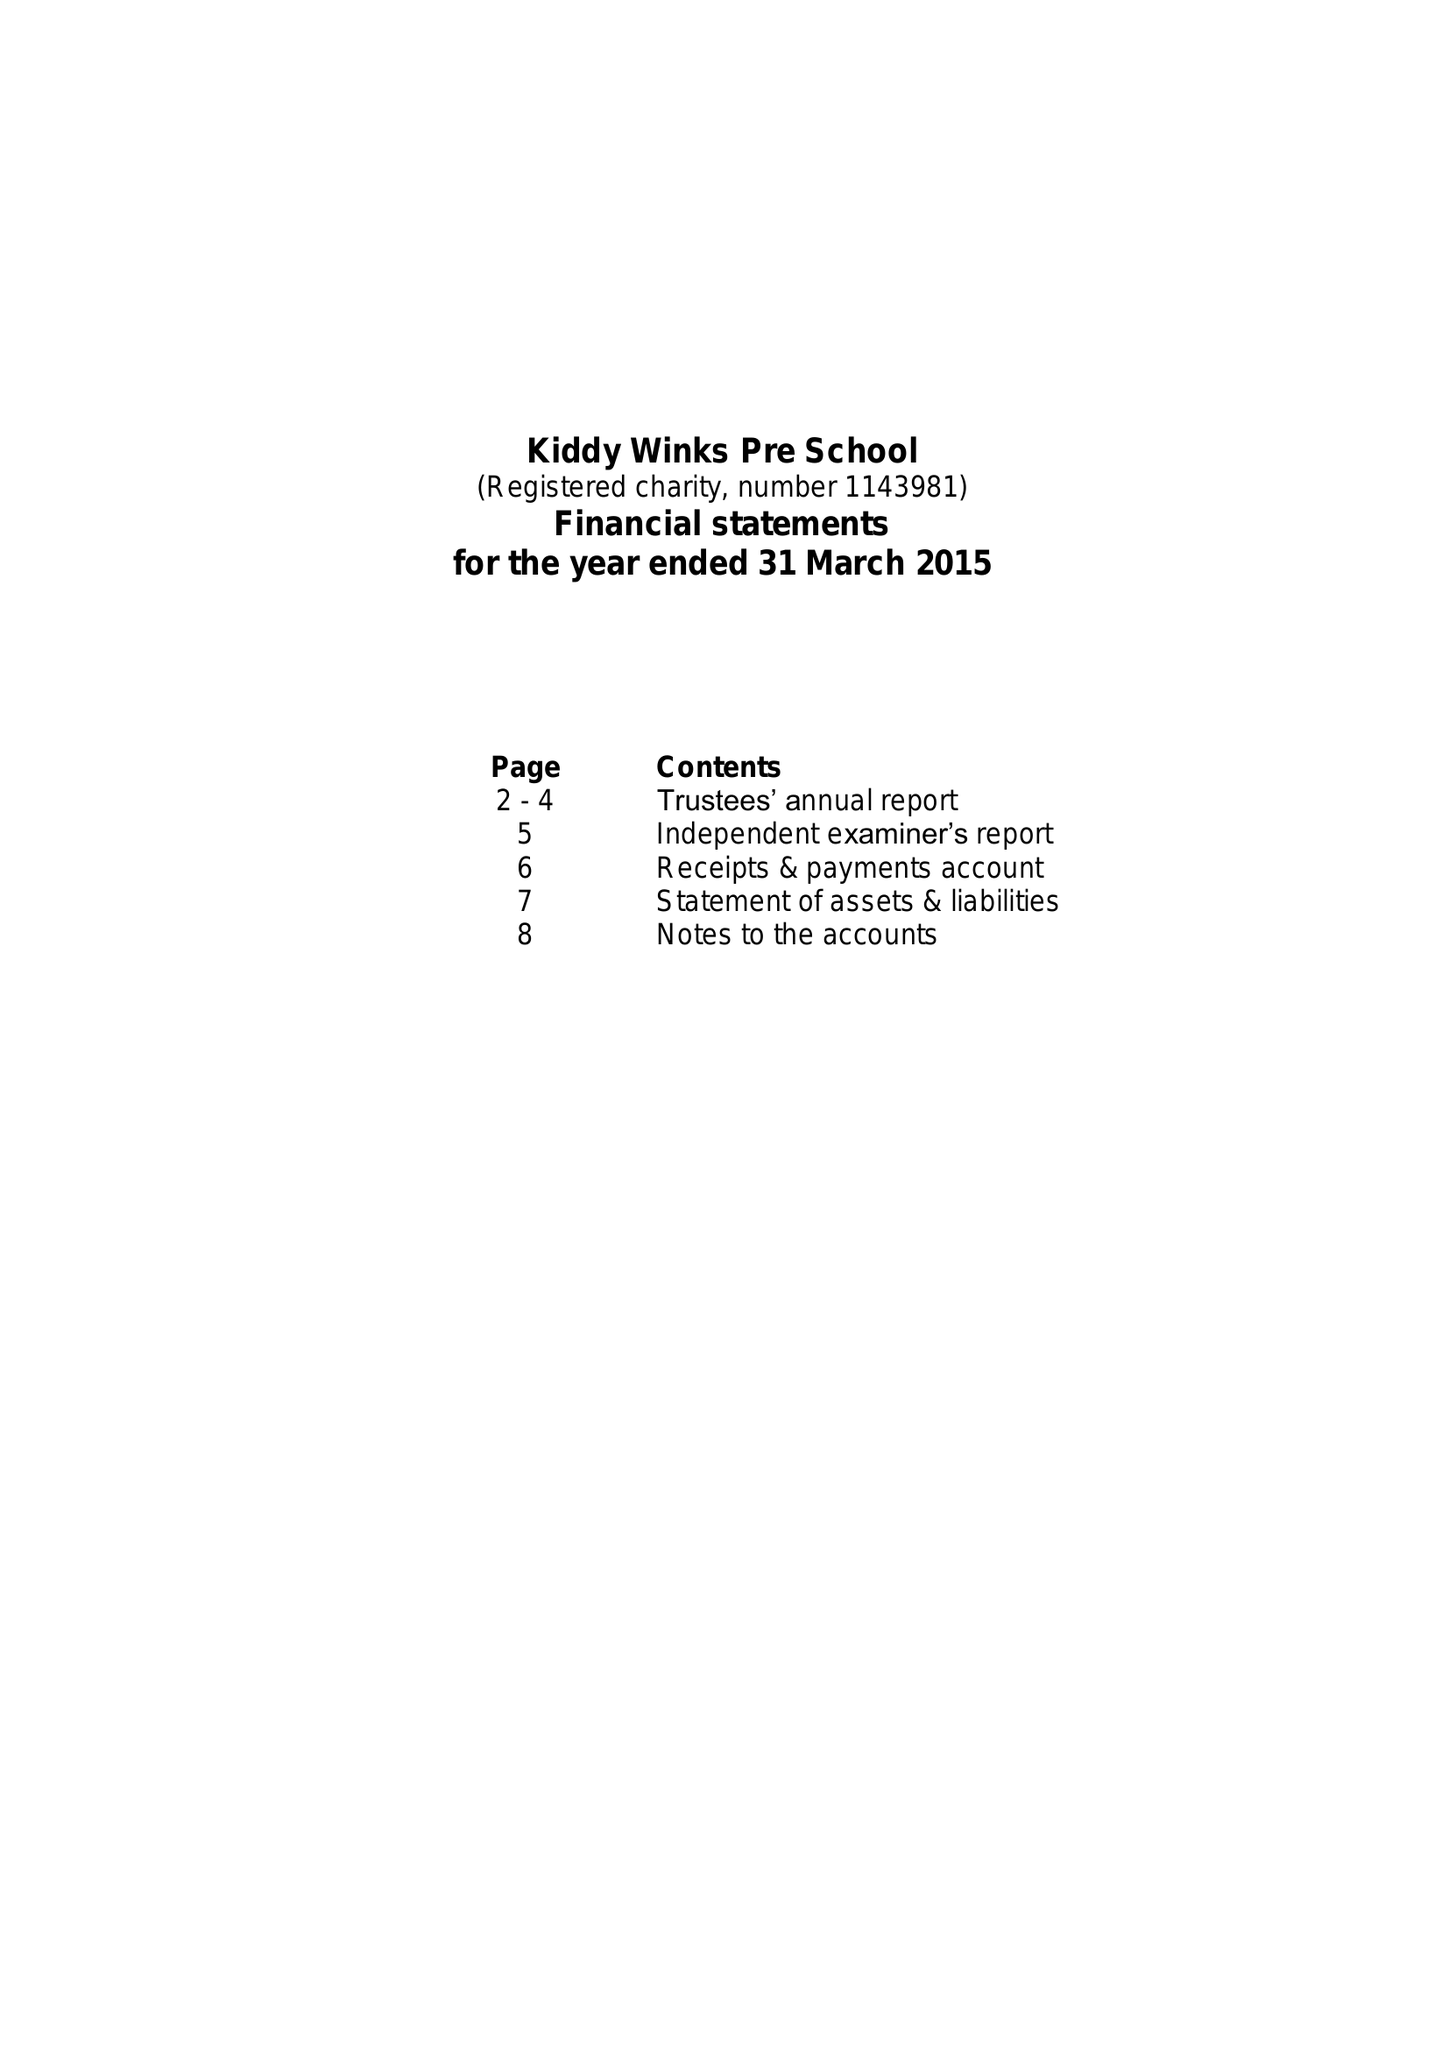What is the value for the address__post_town?
Answer the question using a single word or phrase. NOTTINGHAM 